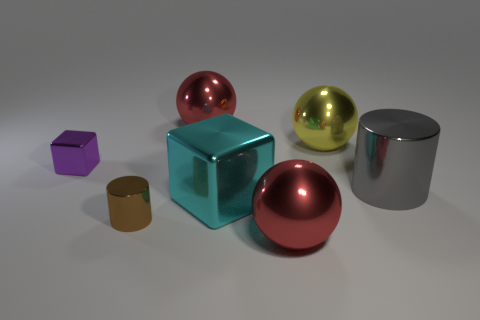Add 1 big cyan blocks. How many objects exist? 8 Subtract all cubes. How many objects are left? 5 Add 4 cyan blocks. How many cyan blocks are left? 5 Add 5 large brown cubes. How many large brown cubes exist? 5 Subtract 0 red cylinders. How many objects are left? 7 Subtract all yellow things. Subtract all purple rubber cylinders. How many objects are left? 6 